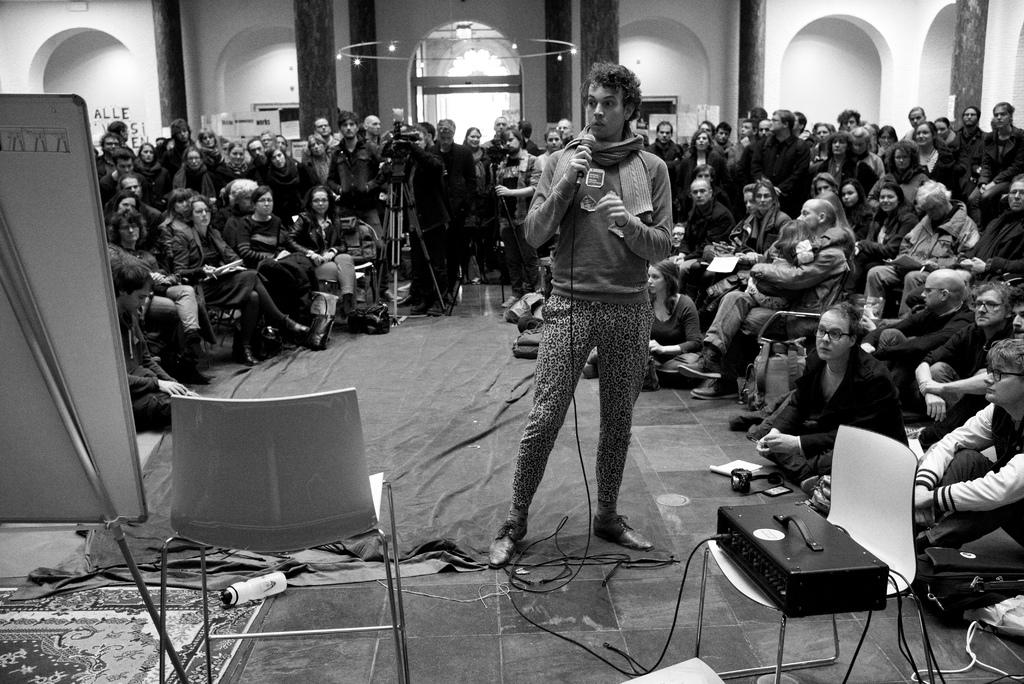What are the people in the image doing? There is a group of people sitting on chairs, and some people are standing on the floor. What type of furniture is present in the image? There are chairs in the image. What else can be seen in the image besides the people and chairs? There is a board in the image. How many chickens are on the board in the image? There are no chickens present in the image; it only features people, chairs, and a board. What type of song is being sung by the people in the image? There is no indication in the image that the people are singing a song. 